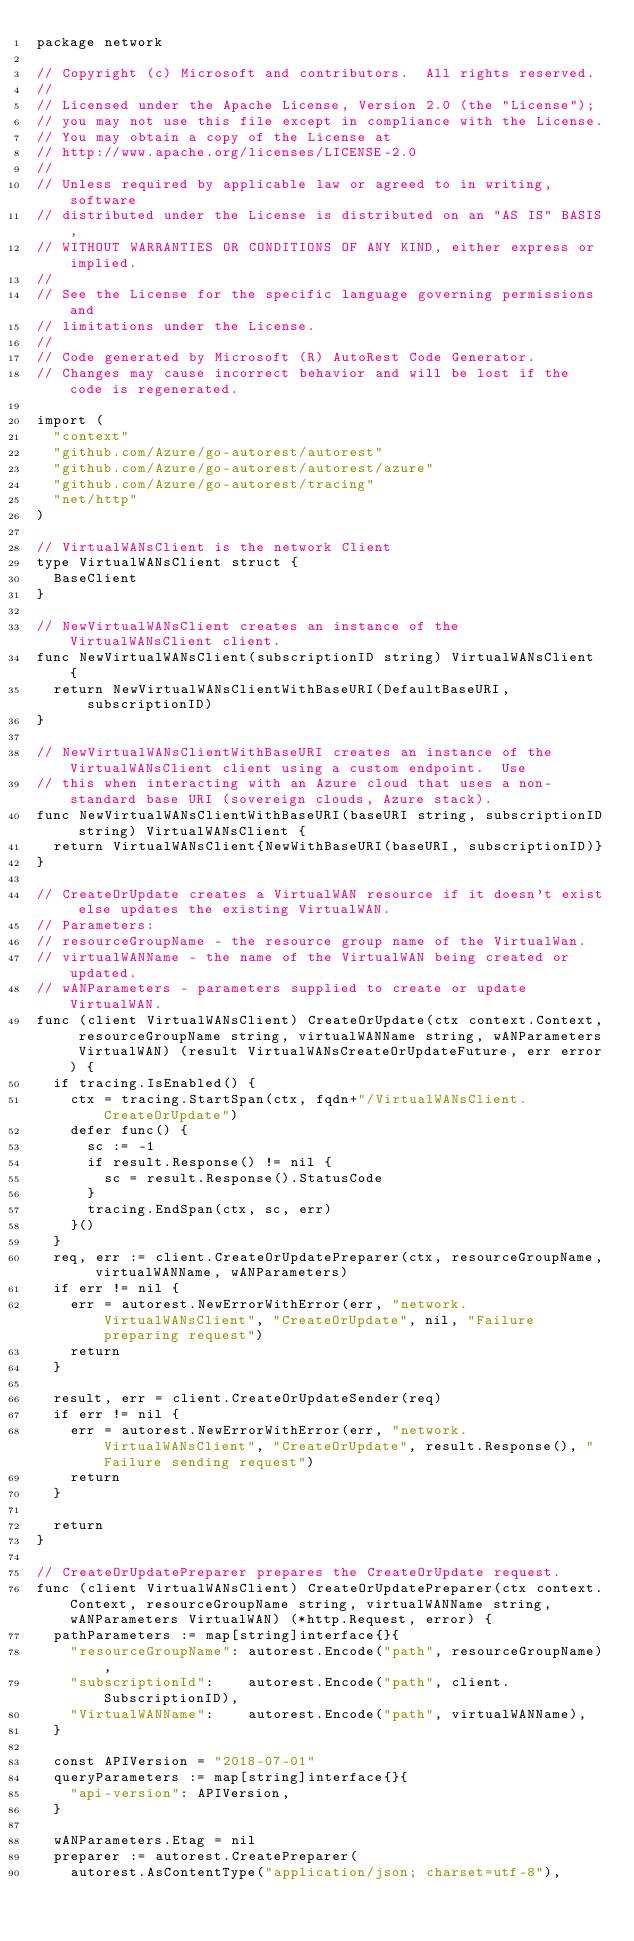Convert code to text. <code><loc_0><loc_0><loc_500><loc_500><_Go_>package network

// Copyright (c) Microsoft and contributors.  All rights reserved.
//
// Licensed under the Apache License, Version 2.0 (the "License");
// you may not use this file except in compliance with the License.
// You may obtain a copy of the License at
// http://www.apache.org/licenses/LICENSE-2.0
//
// Unless required by applicable law or agreed to in writing, software
// distributed under the License is distributed on an "AS IS" BASIS,
// WITHOUT WARRANTIES OR CONDITIONS OF ANY KIND, either express or implied.
//
// See the License for the specific language governing permissions and
// limitations under the License.
//
// Code generated by Microsoft (R) AutoRest Code Generator.
// Changes may cause incorrect behavior and will be lost if the code is regenerated.

import (
	"context"
	"github.com/Azure/go-autorest/autorest"
	"github.com/Azure/go-autorest/autorest/azure"
	"github.com/Azure/go-autorest/tracing"
	"net/http"
)

// VirtualWANsClient is the network Client
type VirtualWANsClient struct {
	BaseClient
}

// NewVirtualWANsClient creates an instance of the VirtualWANsClient client.
func NewVirtualWANsClient(subscriptionID string) VirtualWANsClient {
	return NewVirtualWANsClientWithBaseURI(DefaultBaseURI, subscriptionID)
}

// NewVirtualWANsClientWithBaseURI creates an instance of the VirtualWANsClient client using a custom endpoint.  Use
// this when interacting with an Azure cloud that uses a non-standard base URI (sovereign clouds, Azure stack).
func NewVirtualWANsClientWithBaseURI(baseURI string, subscriptionID string) VirtualWANsClient {
	return VirtualWANsClient{NewWithBaseURI(baseURI, subscriptionID)}
}

// CreateOrUpdate creates a VirtualWAN resource if it doesn't exist else updates the existing VirtualWAN.
// Parameters:
// resourceGroupName - the resource group name of the VirtualWan.
// virtualWANName - the name of the VirtualWAN being created or updated.
// wANParameters - parameters supplied to create or update VirtualWAN.
func (client VirtualWANsClient) CreateOrUpdate(ctx context.Context, resourceGroupName string, virtualWANName string, wANParameters VirtualWAN) (result VirtualWANsCreateOrUpdateFuture, err error) {
	if tracing.IsEnabled() {
		ctx = tracing.StartSpan(ctx, fqdn+"/VirtualWANsClient.CreateOrUpdate")
		defer func() {
			sc := -1
			if result.Response() != nil {
				sc = result.Response().StatusCode
			}
			tracing.EndSpan(ctx, sc, err)
		}()
	}
	req, err := client.CreateOrUpdatePreparer(ctx, resourceGroupName, virtualWANName, wANParameters)
	if err != nil {
		err = autorest.NewErrorWithError(err, "network.VirtualWANsClient", "CreateOrUpdate", nil, "Failure preparing request")
		return
	}

	result, err = client.CreateOrUpdateSender(req)
	if err != nil {
		err = autorest.NewErrorWithError(err, "network.VirtualWANsClient", "CreateOrUpdate", result.Response(), "Failure sending request")
		return
	}

	return
}

// CreateOrUpdatePreparer prepares the CreateOrUpdate request.
func (client VirtualWANsClient) CreateOrUpdatePreparer(ctx context.Context, resourceGroupName string, virtualWANName string, wANParameters VirtualWAN) (*http.Request, error) {
	pathParameters := map[string]interface{}{
		"resourceGroupName": autorest.Encode("path", resourceGroupName),
		"subscriptionId":    autorest.Encode("path", client.SubscriptionID),
		"VirtualWANName":    autorest.Encode("path", virtualWANName),
	}

	const APIVersion = "2018-07-01"
	queryParameters := map[string]interface{}{
		"api-version": APIVersion,
	}

	wANParameters.Etag = nil
	preparer := autorest.CreatePreparer(
		autorest.AsContentType("application/json; charset=utf-8"),</code> 